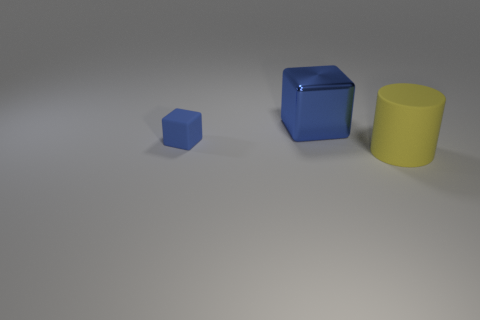Are there any other things that have the same shape as the blue metal object?
Your answer should be compact. Yes. There is a blue object right of the matte thing left of the cylinder; what shape is it?
Offer a terse response. Cube. What number of cubes are shiny objects or blue rubber objects?
Your response must be concise. 2. What is the material of the large thing that is the same color as the small block?
Make the answer very short. Metal. Does the matte thing on the left side of the yellow matte cylinder have the same shape as the large object on the left side of the big yellow thing?
Your answer should be very brief. Yes. The thing that is both behind the large matte cylinder and in front of the blue metallic block is what color?
Make the answer very short. Blue. There is a big shiny block; does it have the same color as the rubber object that is left of the yellow rubber cylinder?
Ensure brevity in your answer.  Yes. There is a thing that is right of the small object and in front of the blue shiny object; what size is it?
Provide a short and direct response. Large. What number of other things are the same color as the tiny rubber object?
Keep it short and to the point. 1. How big is the block on the right side of the blue thing that is on the left side of the blue cube behind the tiny blue rubber block?
Ensure brevity in your answer.  Large. 